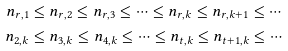<formula> <loc_0><loc_0><loc_500><loc_500>n _ { r , 1 } & \leq n _ { r , 2 } \leq n _ { r , 3 } \leq \cdots \leq n _ { r , k } \leq n _ { r , k + 1 } \leq \cdots \\ n _ { 2 , k } & \leq n _ { 3 , k } \leq n _ { 4 , k } \leq \cdots \leq n _ { t , k } \leq n _ { t + 1 , k } \leq \cdots</formula> 